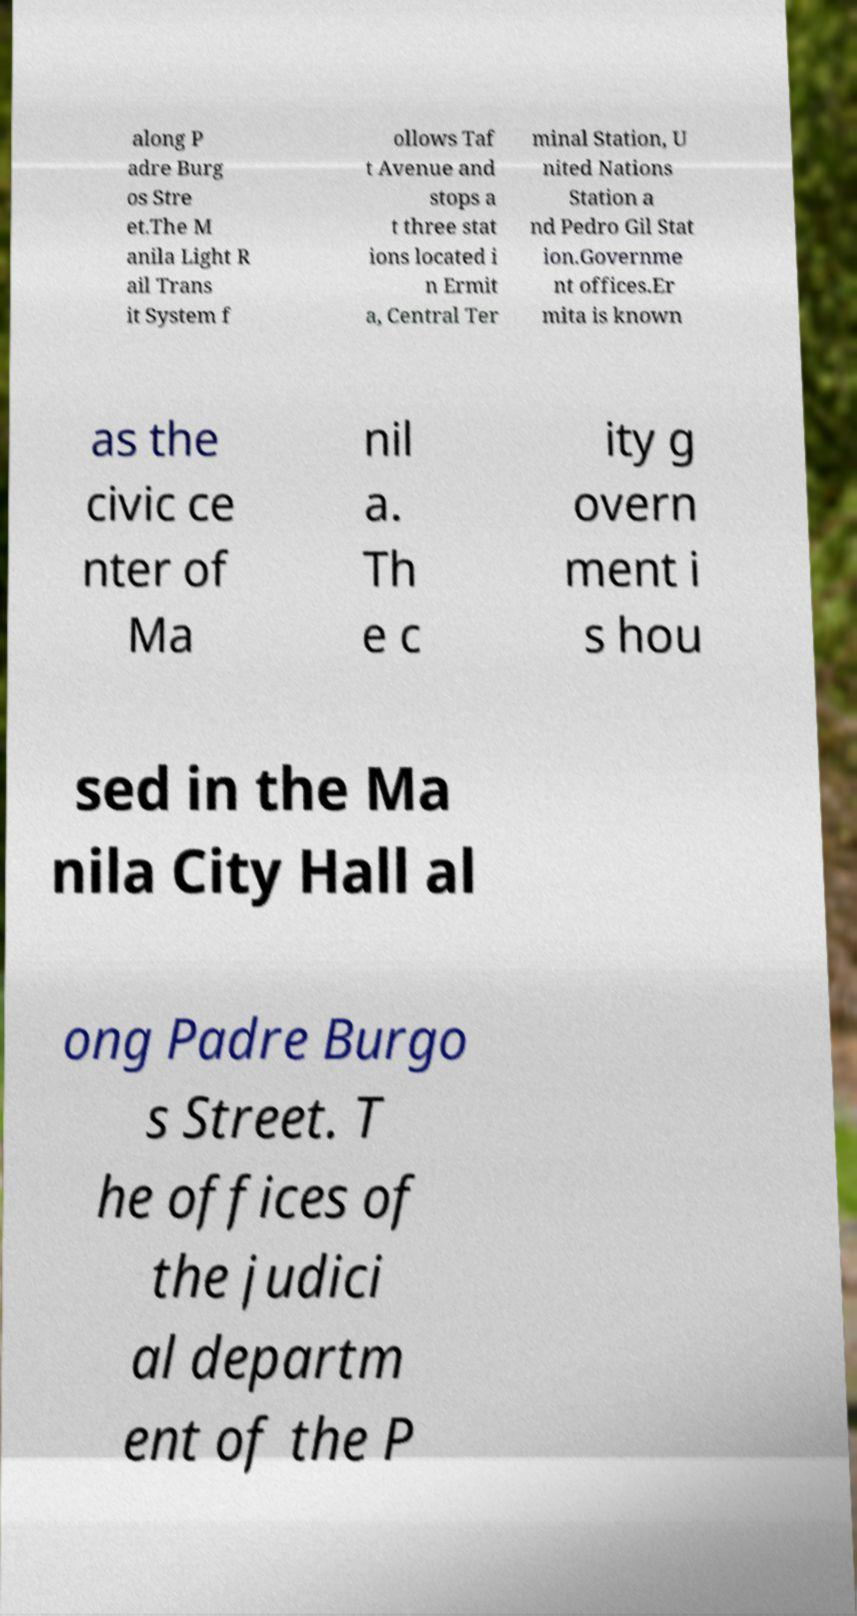I need the written content from this picture converted into text. Can you do that? along P adre Burg os Stre et.The M anila Light R ail Trans it System f ollows Taf t Avenue and stops a t three stat ions located i n Ermit a, Central Ter minal Station, U nited Nations Station a nd Pedro Gil Stat ion.Governme nt offices.Er mita is known as the civic ce nter of Ma nil a. Th e c ity g overn ment i s hou sed in the Ma nila City Hall al ong Padre Burgo s Street. T he offices of the judici al departm ent of the P 